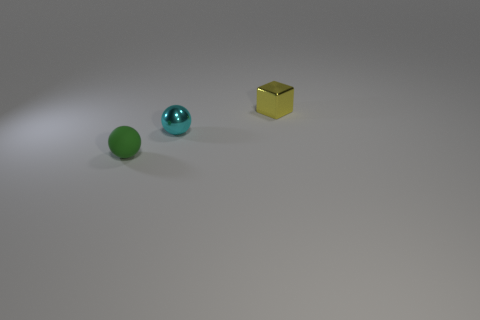Add 2 small objects. How many objects exist? 5 Subtract all green spheres. How many spheres are left? 1 Subtract all blocks. How many objects are left? 2 Subtract all purple balls. Subtract all blue cylinders. How many balls are left? 2 Subtract all blue blocks. How many red spheres are left? 0 Subtract all cyan shiny things. Subtract all yellow things. How many objects are left? 1 Add 2 small cyan metallic spheres. How many small cyan metallic spheres are left? 3 Add 3 purple rubber objects. How many purple rubber objects exist? 3 Subtract 0 red cubes. How many objects are left? 3 Subtract 1 blocks. How many blocks are left? 0 